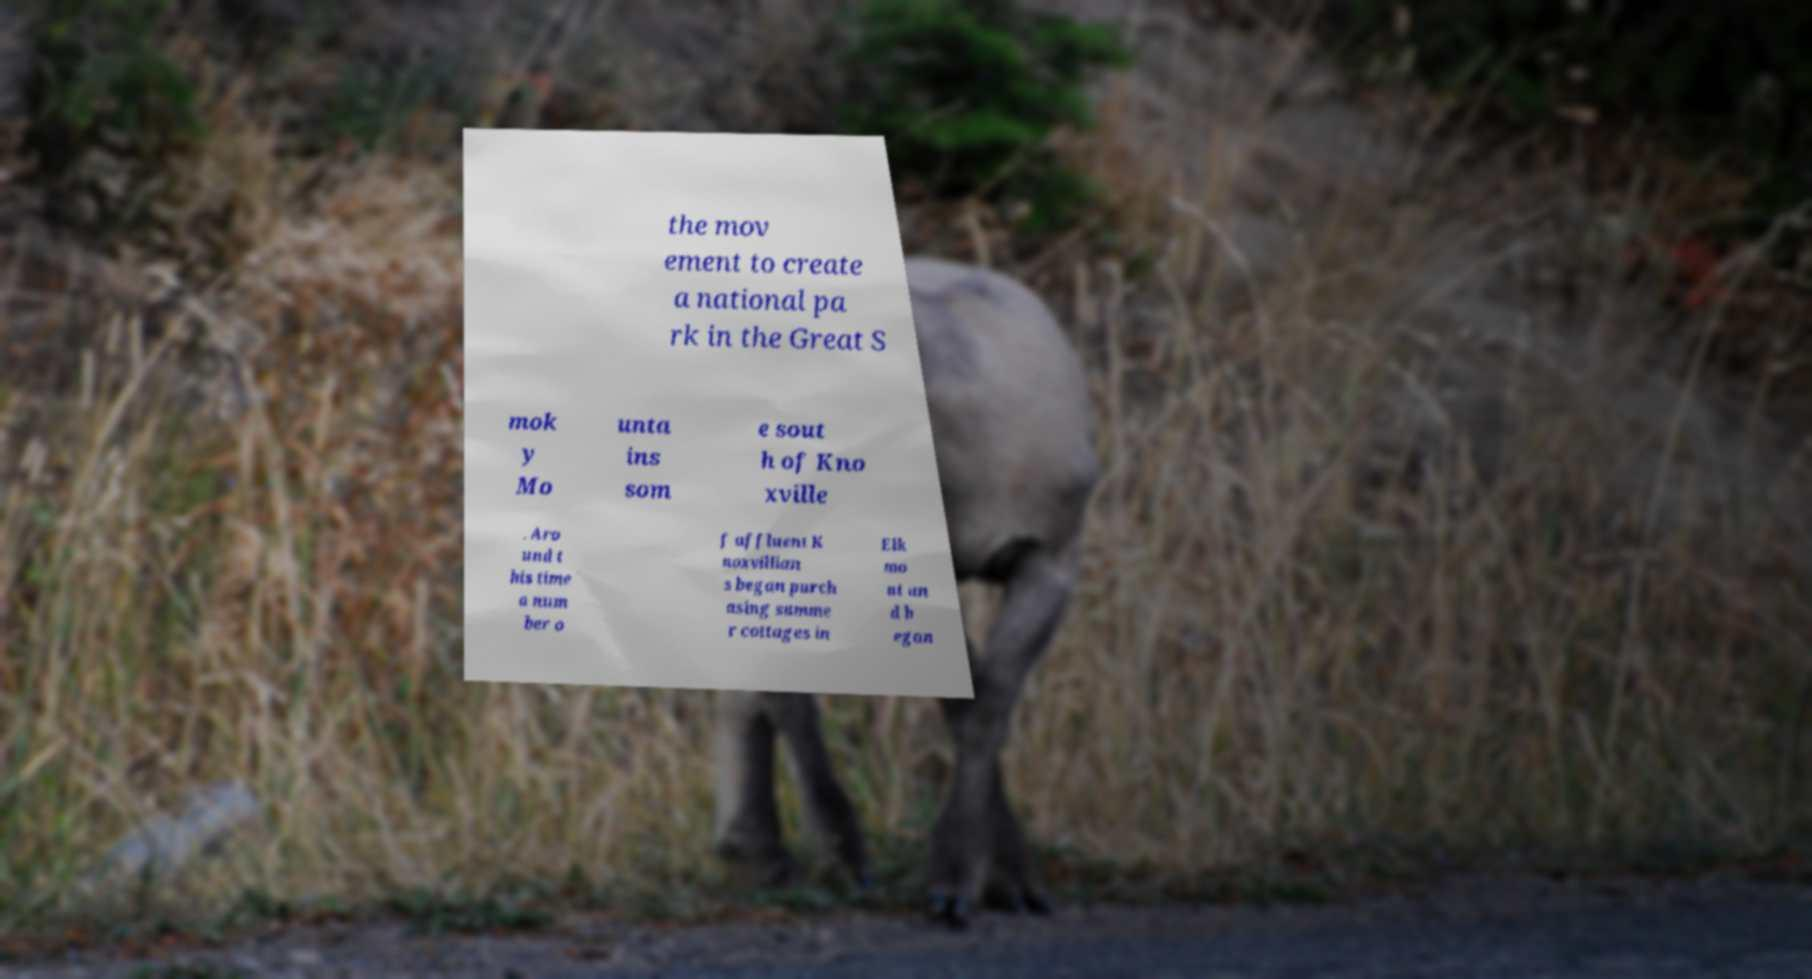There's text embedded in this image that I need extracted. Can you transcribe it verbatim? the mov ement to create a national pa rk in the Great S mok y Mo unta ins som e sout h of Kno xville . Aro und t his time a num ber o f affluent K noxvillian s began purch asing summe r cottages in Elk mo nt an d b egan 